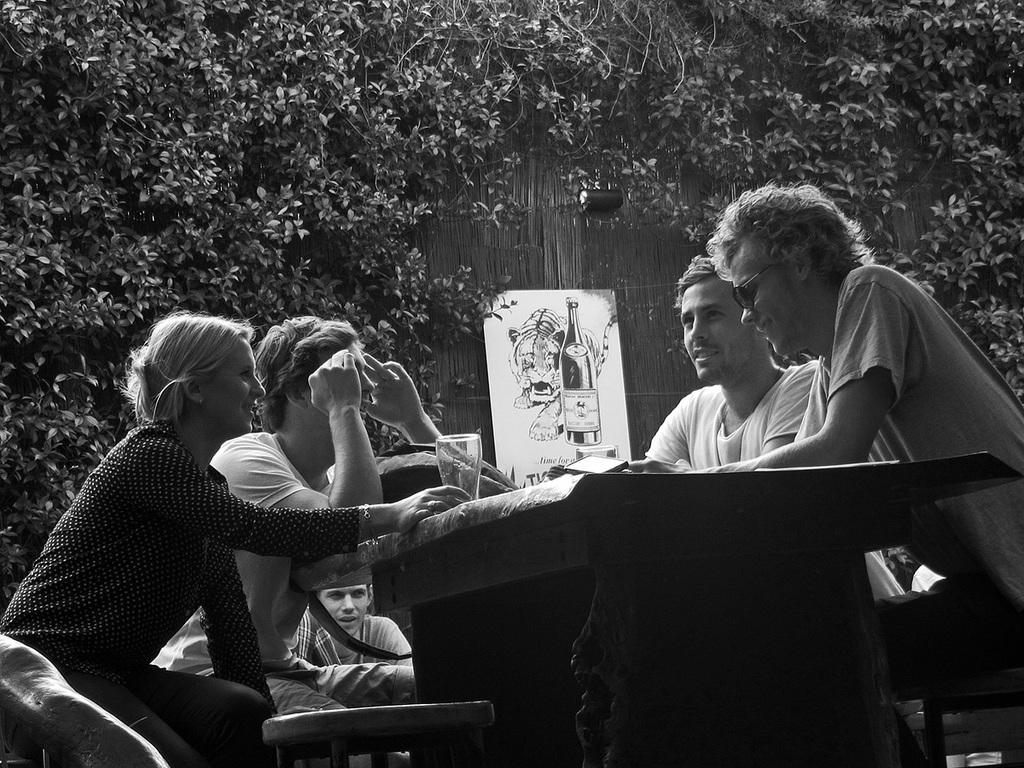What are the people in the image doing? The people in the image are sitting on chairs and talking. What can be seen in the background of the image? There is a board, a tree, and a wall in the background of the image. What type of bread is being served at the table in the image? There is no table or bread present in the image. What is the opinion of the people sitting on chairs about the current political situation? The provided facts do not give any information about the people's opinions on any topic, including politics. 